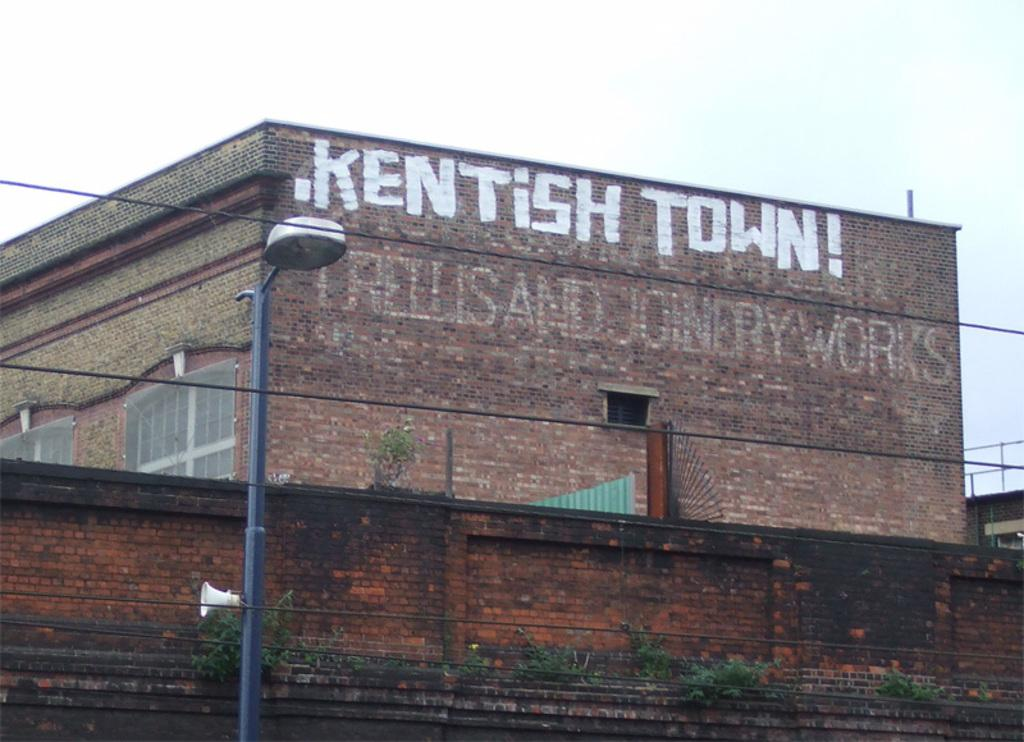What can be seen running through the image? There are wires in the image. What structure is present in the image that supports the wires? There is an electric pole in the image. What device is attached to the wires in the image? There is a loudspeaker in the image. What is the background of the image made up of? The sky is visible in the background of the image. What type of vegetation can be seen in the image? There are plants in the image. What type of building is visible in the image? There is a building with windows in the image. Are there any other objects present in the image? Yes, there are some objects in the image. What type of pain is being expressed by the playground in the image? There is no playground present in the image, so it cannot express any pain. 